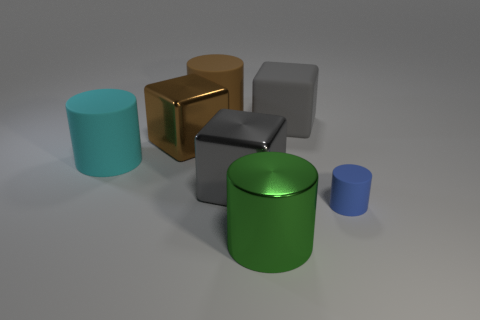Add 2 brown cubes. How many objects exist? 9 Subtract all metallic blocks. How many blocks are left? 1 Subtract all blue cylinders. Subtract all cyan blocks. How many cylinders are left? 3 Subtract all gray cubes. How many cubes are left? 1 Subtract all yellow cubes. How many green cylinders are left? 1 Subtract all green metal cylinders. Subtract all matte things. How many objects are left? 2 Add 4 small blue matte cylinders. How many small blue matte cylinders are left? 5 Add 5 brown metal objects. How many brown metal objects exist? 6 Subtract 0 blue spheres. How many objects are left? 7 Subtract all cubes. How many objects are left? 4 